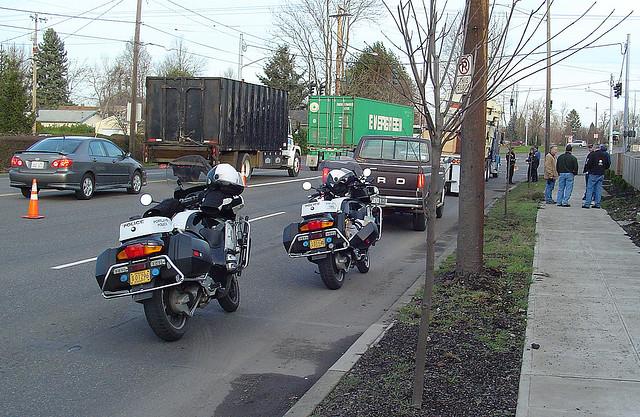What kind of traffic marker is standing in the middle of the road?
Give a very brief answer. Cone. Which color motorcycle has a noticeable helmet on the seat?
Be succinct. Black. Are there any cones in the picture?
Concise answer only. Yes. How many motorcycles are there?
Quick response, please. 2. 